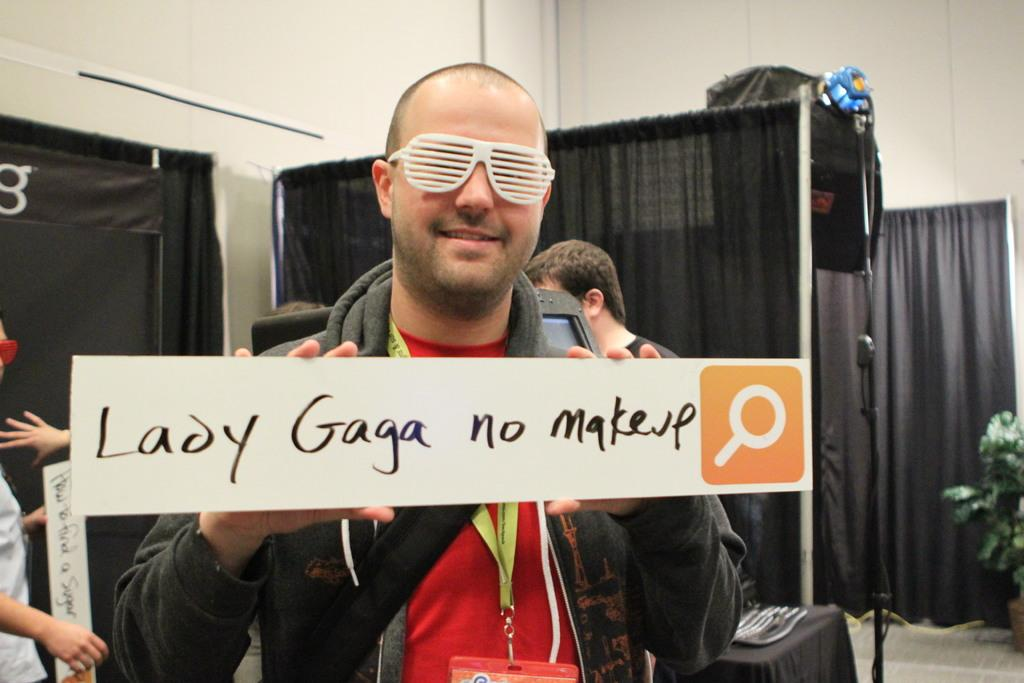What are the persons in the image doing? The persons in the image are standing and holding boards in their hands. What can be seen in the background of the image? There are curtains in the image. Are there any plants visible in the image? Yes, there are houseplants in the image. What else can be seen on the tables in the image? There are objects on the tables in the image. What type of salt is being used to attack the houseplants in the image? There is no salt or attack present in the image; the persons are holding boards, and there are houseplants in the image. How many parcels can be seen on the tables in the image? There is no mention of parcels in the image; the tables have objects on them, but their nature is not specified. 